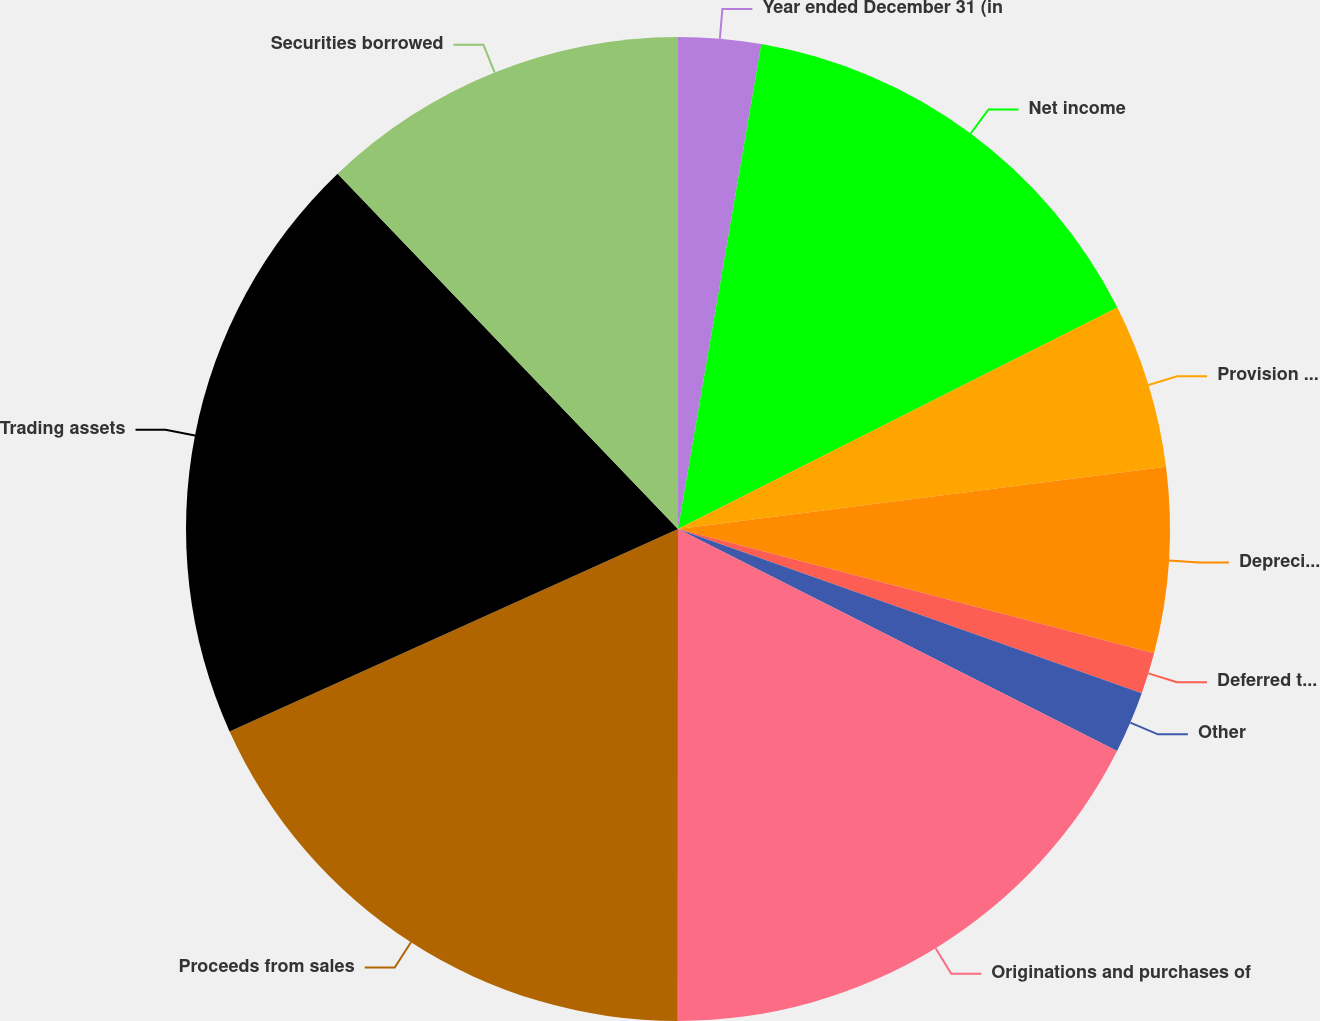<chart> <loc_0><loc_0><loc_500><loc_500><pie_chart><fcel>Year ended December 31 (in<fcel>Net income<fcel>Provision for credit losses<fcel>Depreciation and amortization<fcel>Deferred tax expense<fcel>Other<fcel>Originations and purchases of<fcel>Proceeds from sales<fcel>Trading assets<fcel>Securities borrowed<nl><fcel>2.71%<fcel>14.86%<fcel>5.41%<fcel>6.08%<fcel>1.36%<fcel>2.03%<fcel>17.56%<fcel>18.24%<fcel>19.59%<fcel>12.16%<nl></chart> 